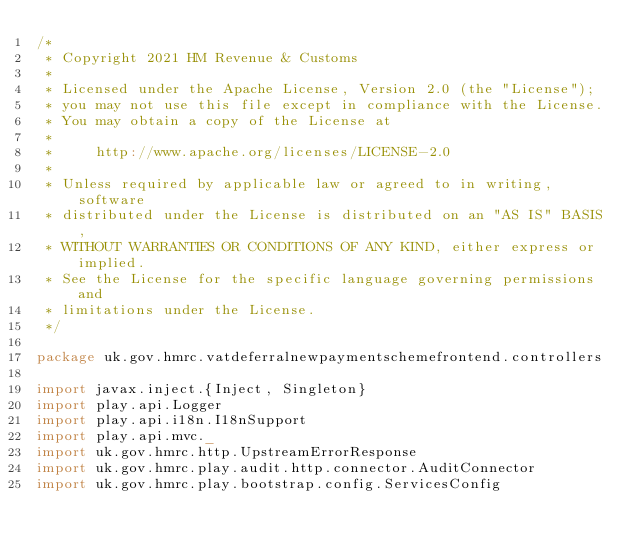<code> <loc_0><loc_0><loc_500><loc_500><_Scala_>/*
 * Copyright 2021 HM Revenue & Customs
 *
 * Licensed under the Apache License, Version 2.0 (the "License");
 * you may not use this file except in compliance with the License.
 * You may obtain a copy of the License at
 *
 *     http://www.apache.org/licenses/LICENSE-2.0
 *
 * Unless required by applicable law or agreed to in writing, software
 * distributed under the License is distributed on an "AS IS" BASIS,
 * WITHOUT WARRANTIES OR CONDITIONS OF ANY KIND, either express or implied.
 * See the License for the specific language governing permissions and
 * limitations under the License.
 */

package uk.gov.hmrc.vatdeferralnewpaymentschemefrontend.controllers

import javax.inject.{Inject, Singleton}
import play.api.Logger
import play.api.i18n.I18nSupport
import play.api.mvc._
import uk.gov.hmrc.http.UpstreamErrorResponse
import uk.gov.hmrc.play.audit.http.connector.AuditConnector
import uk.gov.hmrc.play.bootstrap.config.ServicesConfig</code> 